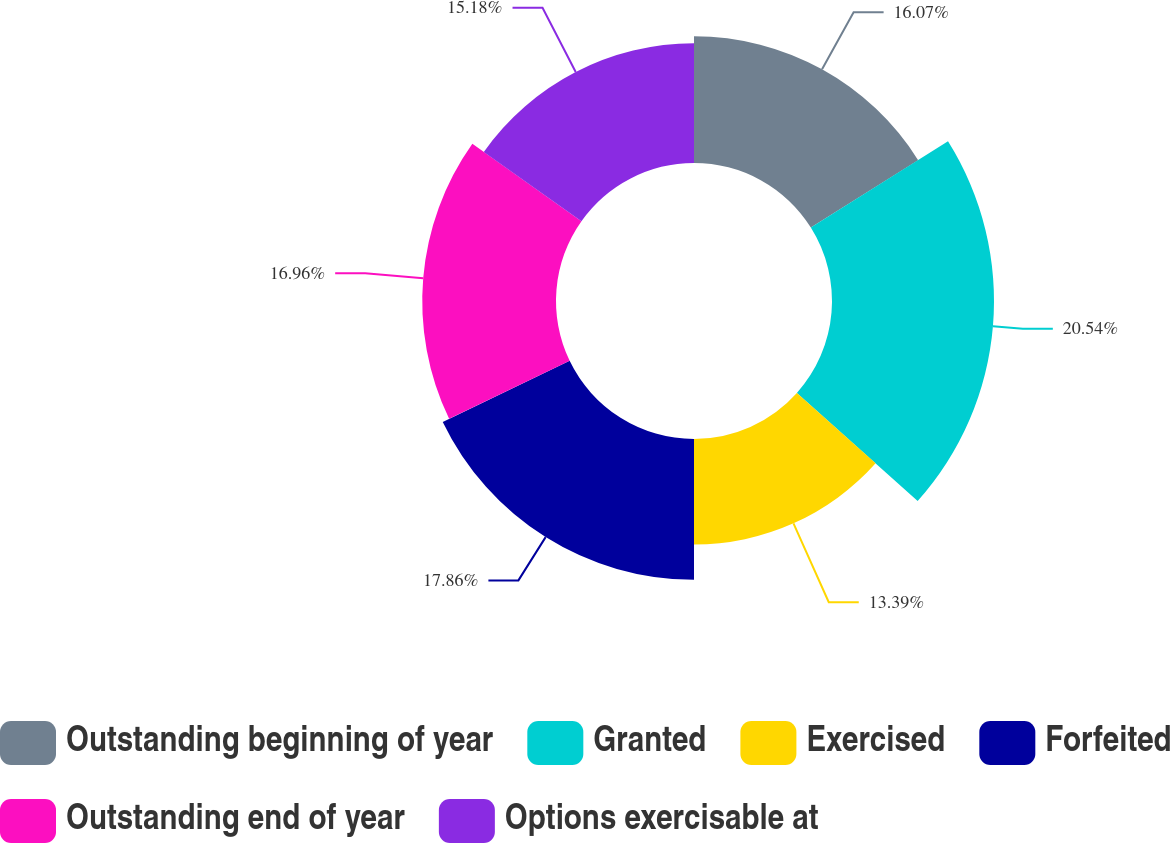<chart> <loc_0><loc_0><loc_500><loc_500><pie_chart><fcel>Outstanding beginning of year<fcel>Granted<fcel>Exercised<fcel>Forfeited<fcel>Outstanding end of year<fcel>Options exercisable at<nl><fcel>16.07%<fcel>20.54%<fcel>13.39%<fcel>17.86%<fcel>16.96%<fcel>15.18%<nl></chart> 